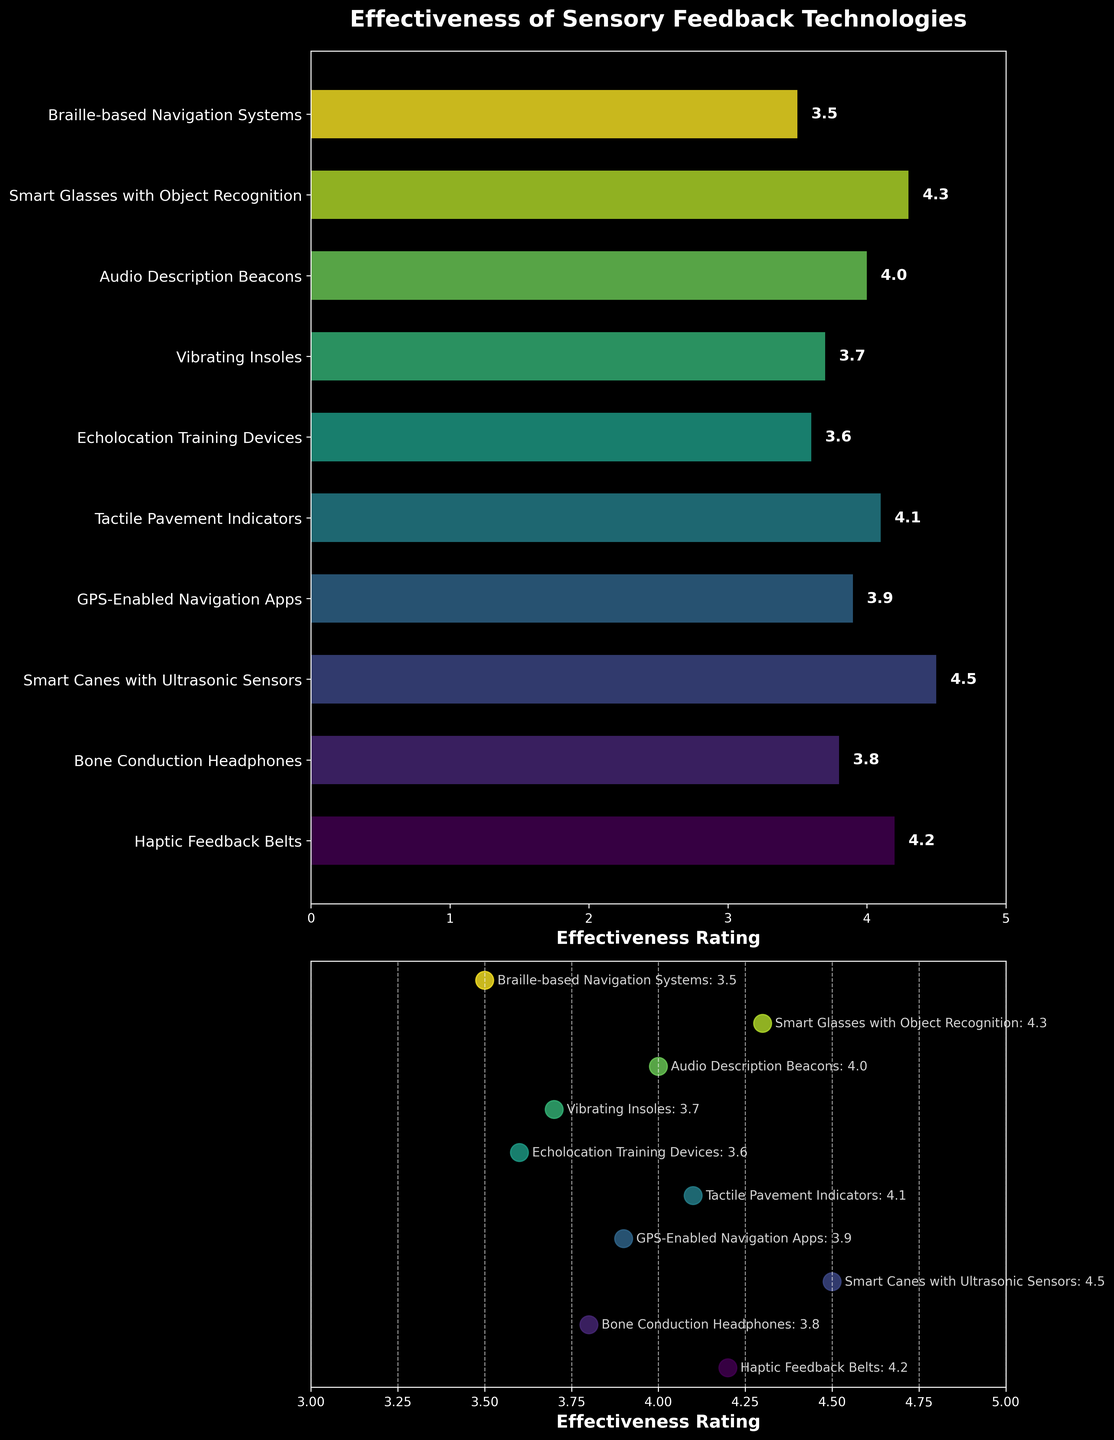What is the title of the bar plot? The title of the bar plot is placed at the top of the first subplot. It provides a succinct summary of what the bar plot represents.
Answer: Effectiveness of Sensory Feedback Technologies What is the highest effectiveness rating among the technologies? Scan through the bars in the bar plot. Identify the longest bar and read its corresponding value, which is annotated near the end of the bar.
Answer: 4.5 Which technology has the lowest effectiveness rating? Locate the bar with the shortest length on the bar plot, then read its label from the y-axis and check its annotated rating.
Answer: Braille-based Navigation Systems What is the effectiveness rating of Vibrating Insoles? Look for "Vibrating Insoles" along the y-axis in the bar plot. Then, read the corresponding annotated value for the bar.
Answer: 3.7 Of the technologies listed, how many have an effectiveness rating of 4.0 or higher? Examine each bar and its annotated value. Count the number of bars with a rating of 4.0 or higher.
Answer: 6 On the scatter plot, which technology with an effectiveness rating of 4.0 is indicated? Identify the point on the scatter plot at the rating of 4.0. Look for the label annotating that point to find the corresponding technology.
Answer: Audio Description Beacons Which two technologies have ratings that differ by the smallest amount? Determine the difference between each pair of adjacent effectiveness ratings as shown in the bar plot, then identify the pair with the smallest difference.
Answer: Bone Conduction Headphones and GPS-Enabled Navigation Apps What is the average effectiveness rating of the listed technologies? Sum the effectiveness ratings for all technologies and divide by the number of technologies. Ratings are: (4.2 + 3.8 + 4.5 + 3.9 + 4.1 + 3.6 + 3.7 + 4.0 + 4.3 + 3.5). Sum = 39.6; Number of technologies = 10; Average: 39.6/10 = 3.96
Answer: 3.96 What is the range of effectiveness ratings in the scatter plot? Identify the highest and lowest points in the scatter plot. The range is the difference between these two points. Highest rating = 4.5, Lowest rating = 3.5; Range = 4.5 - 3.5 = 1
Answer: 1 